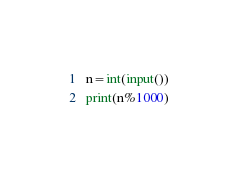<code> <loc_0><loc_0><loc_500><loc_500><_Python_>n=int(input())
print(n%1000)</code> 